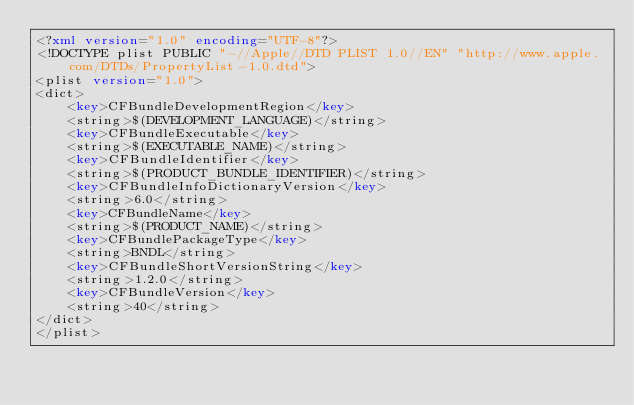<code> <loc_0><loc_0><loc_500><loc_500><_XML_><?xml version="1.0" encoding="UTF-8"?>
<!DOCTYPE plist PUBLIC "-//Apple//DTD PLIST 1.0//EN" "http://www.apple.com/DTDs/PropertyList-1.0.dtd">
<plist version="1.0">
<dict>
	<key>CFBundleDevelopmentRegion</key>
	<string>$(DEVELOPMENT_LANGUAGE)</string>
	<key>CFBundleExecutable</key>
	<string>$(EXECUTABLE_NAME)</string>
	<key>CFBundleIdentifier</key>
	<string>$(PRODUCT_BUNDLE_IDENTIFIER)</string>
	<key>CFBundleInfoDictionaryVersion</key>
	<string>6.0</string>
	<key>CFBundleName</key>
	<string>$(PRODUCT_NAME)</string>
	<key>CFBundlePackageType</key>
	<string>BNDL</string>
	<key>CFBundleShortVersionString</key>
	<string>1.2.0</string>
	<key>CFBundleVersion</key>
	<string>40</string>
</dict>
</plist>
</code> 